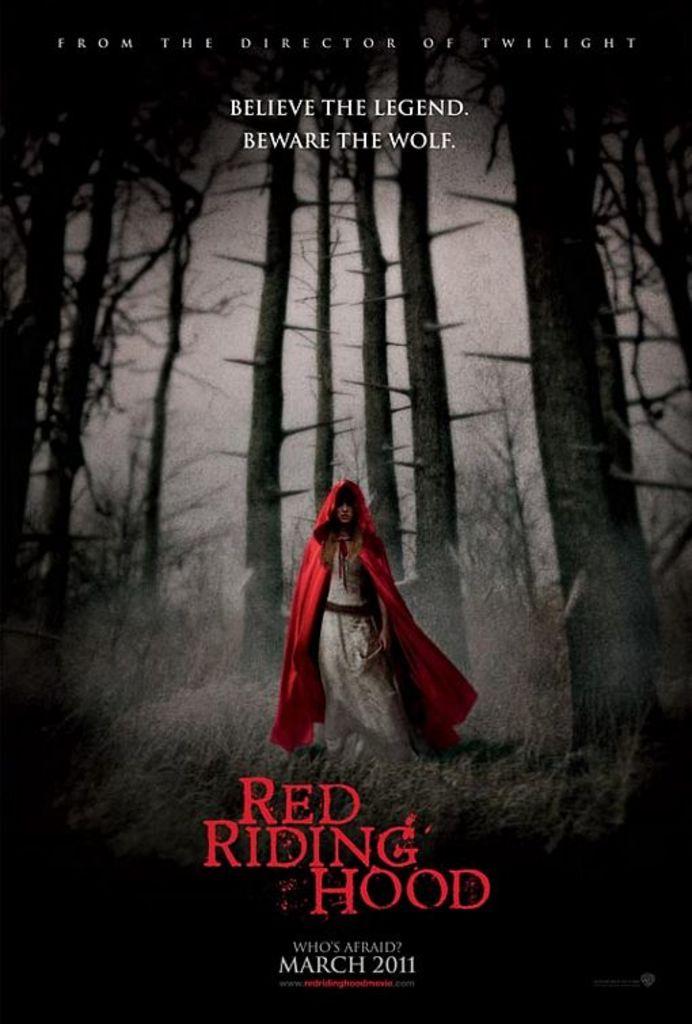What does the advertisement tell you to believe?
Your response must be concise. The legend. 